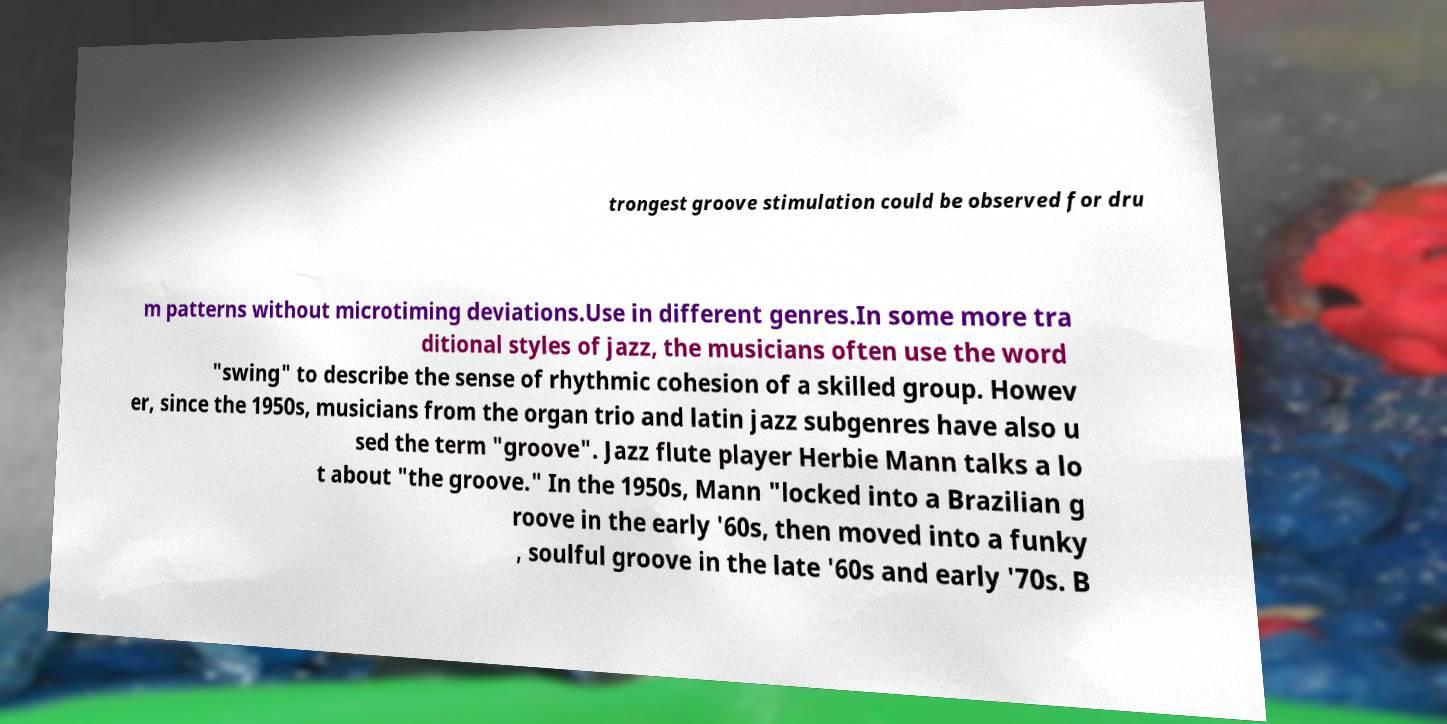For documentation purposes, I need the text within this image transcribed. Could you provide that? trongest groove stimulation could be observed for dru m patterns without microtiming deviations.Use in different genres.In some more tra ditional styles of jazz, the musicians often use the word "swing" to describe the sense of rhythmic cohesion of a skilled group. Howev er, since the 1950s, musicians from the organ trio and latin jazz subgenres have also u sed the term "groove". Jazz flute player Herbie Mann talks a lo t about "the groove." In the 1950s, Mann "locked into a Brazilian g roove in the early '60s, then moved into a funky , soulful groove in the late '60s and early '70s. B 